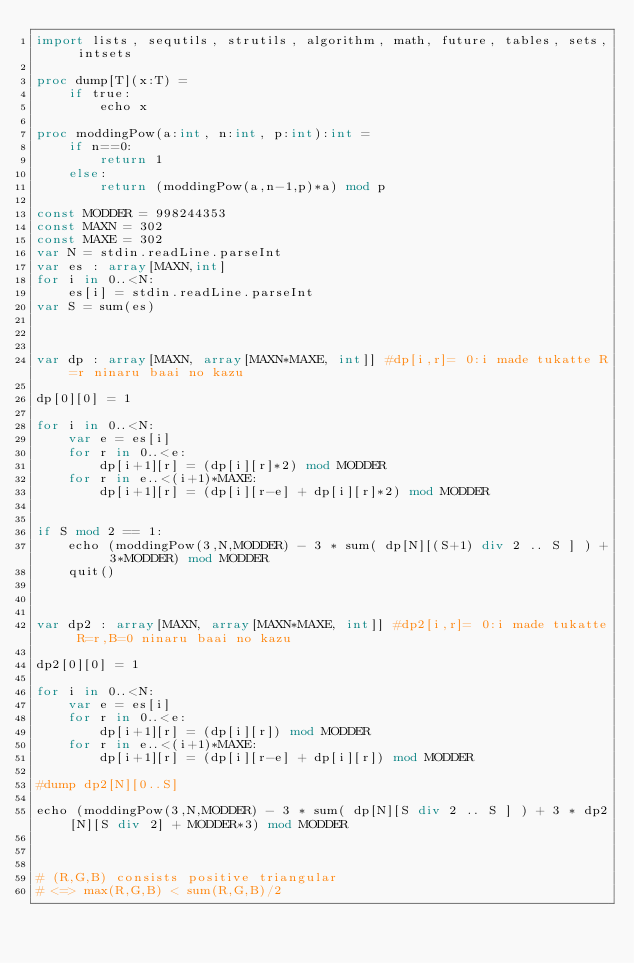Convert code to text. <code><loc_0><loc_0><loc_500><loc_500><_Nim_>import lists, sequtils, strutils, algorithm, math, future, tables, sets, intsets

proc dump[T](x:T) =
    if true:
        echo x

proc moddingPow(a:int, n:int, p:int):int =
    if n==0:
        return 1
    else:
        return (moddingPow(a,n-1,p)*a) mod p

const MODDER = 998244353
const MAXN = 302
const MAXE = 302
var N = stdin.readLine.parseInt
var es : array[MAXN,int]
for i in 0..<N:
    es[i] = stdin.readLine.parseInt
var S = sum(es)



var dp : array[MAXN, array[MAXN*MAXE, int]] #dp[i,r]= 0:i made tukatte R=r ninaru baai no kazu

dp[0][0] = 1

for i in 0..<N:
    var e = es[i]
    for r in 0..<e:
        dp[i+1][r] = (dp[i][r]*2) mod MODDER
    for r in e..<(i+1)*MAXE:
        dp[i+1][r] = (dp[i][r-e] + dp[i][r]*2) mod MODDER


if S mod 2 == 1:
    echo (moddingPow(3,N,MODDER) - 3 * sum( dp[N][(S+1) div 2 .. S ] ) + 3*MODDER) mod MODDER
    quit()



var dp2 : array[MAXN, array[MAXN*MAXE, int]] #dp2[i,r]= 0:i made tukatte R=r,B=0 ninaru baai no kazu

dp2[0][0] = 1

for i in 0..<N:
    var e = es[i]
    for r in 0..<e:
        dp[i+1][r] = (dp[i][r]) mod MODDER
    for r in e..<(i+1)*MAXE:
        dp[i+1][r] = (dp[i][r-e] + dp[i][r]) mod MODDER

#dump dp2[N][0..S]

echo (moddingPow(3,N,MODDER) - 3 * sum( dp[N][S div 2 .. S ] ) + 3 * dp2[N][S div 2] + MODDER*3) mod MODDER



# (R,G,B) consists positive triangular
# <=> max(R,G,B) < sum(R,G,B)/2</code> 